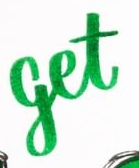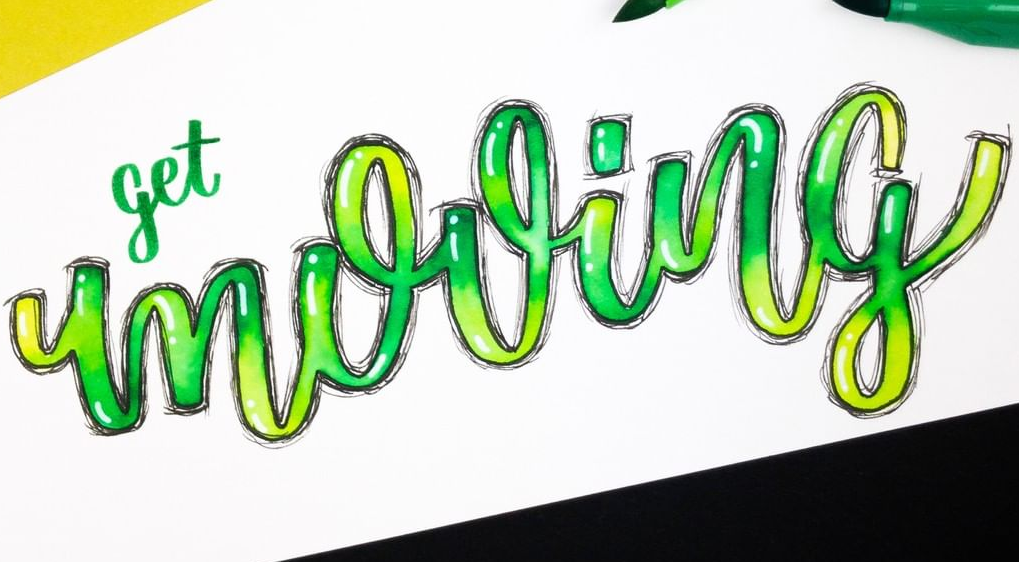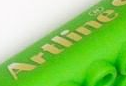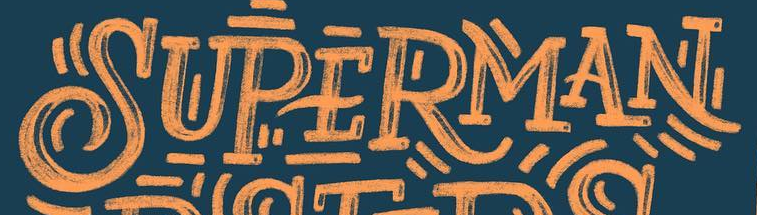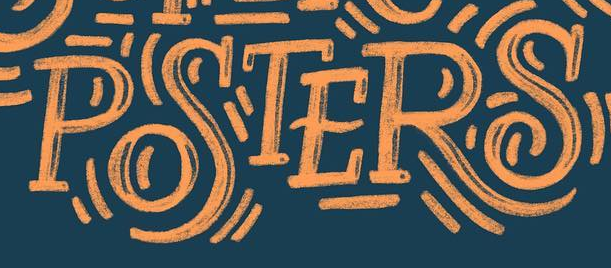Read the text from these images in sequence, separated by a semicolon. get; mooing; Artline; SUPERMAN; POSTERS 